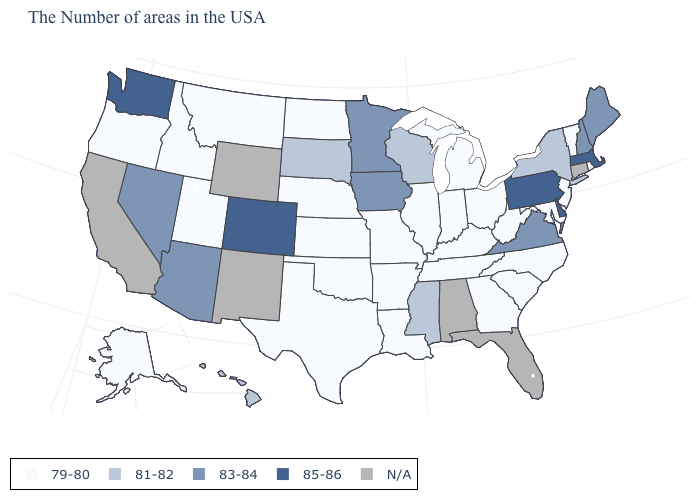What is the value of South Dakota?
Quick response, please. 81-82. What is the value of Virginia?
Concise answer only. 83-84. What is the highest value in the USA?
Keep it brief. 85-86. What is the value of North Carolina?
Keep it brief. 79-80. Does the map have missing data?
Write a very short answer. Yes. Which states have the lowest value in the USA?
Give a very brief answer. Rhode Island, Vermont, New Jersey, Maryland, North Carolina, South Carolina, West Virginia, Ohio, Georgia, Michigan, Kentucky, Indiana, Tennessee, Illinois, Louisiana, Missouri, Arkansas, Kansas, Nebraska, Oklahoma, Texas, North Dakota, Utah, Montana, Idaho, Oregon, Alaska. Does Colorado have the highest value in the West?
Short answer required. Yes. What is the lowest value in the USA?
Keep it brief. 79-80. What is the lowest value in the USA?
Concise answer only. 79-80. How many symbols are there in the legend?
Give a very brief answer. 5. Name the states that have a value in the range N/A?
Short answer required. Connecticut, Florida, Alabama, Wyoming, New Mexico, California. Name the states that have a value in the range 83-84?
Write a very short answer. Maine, New Hampshire, Virginia, Minnesota, Iowa, Arizona, Nevada. Name the states that have a value in the range 79-80?
Keep it brief. Rhode Island, Vermont, New Jersey, Maryland, North Carolina, South Carolina, West Virginia, Ohio, Georgia, Michigan, Kentucky, Indiana, Tennessee, Illinois, Louisiana, Missouri, Arkansas, Kansas, Nebraska, Oklahoma, Texas, North Dakota, Utah, Montana, Idaho, Oregon, Alaska. 